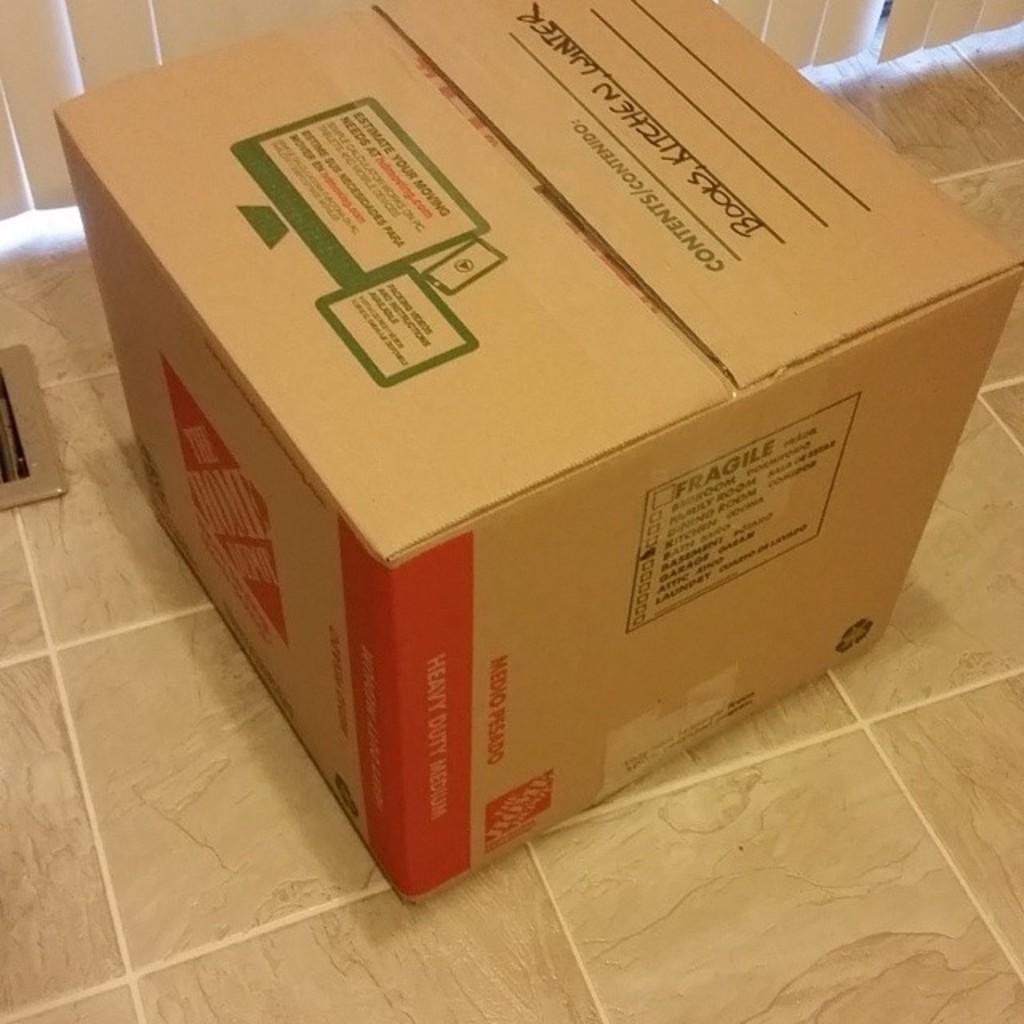What does the writing say is in the box?
Provide a short and direct response. Books, kitchen, winter. Where did they get this box?
Offer a terse response. Home depot. 